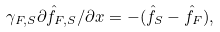Convert formula to latex. <formula><loc_0><loc_0><loc_500><loc_500>\gamma _ { F , S } \partial \hat { f } _ { F , S } / \partial x = - ( \hat { f } _ { S } - \hat { f } _ { F } ) ,</formula> 